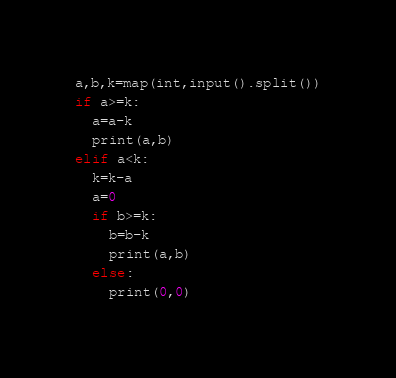<code> <loc_0><loc_0><loc_500><loc_500><_Python_>a,b,k=map(int,input().split())
if a>=k:
  a=a-k
  print(a,b)
elif a<k:
  k=k-a
  a=0
  if b>=k:
    b=b-k
    print(a,b)
  else:
    print(0,0)</code> 